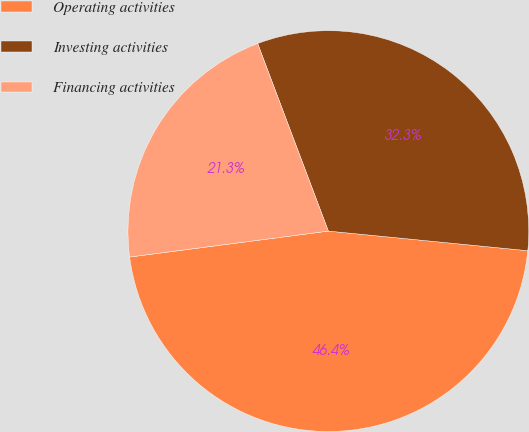<chart> <loc_0><loc_0><loc_500><loc_500><pie_chart><fcel>Operating activities<fcel>Investing activities<fcel>Financing activities<nl><fcel>46.37%<fcel>32.3%<fcel>21.33%<nl></chart> 